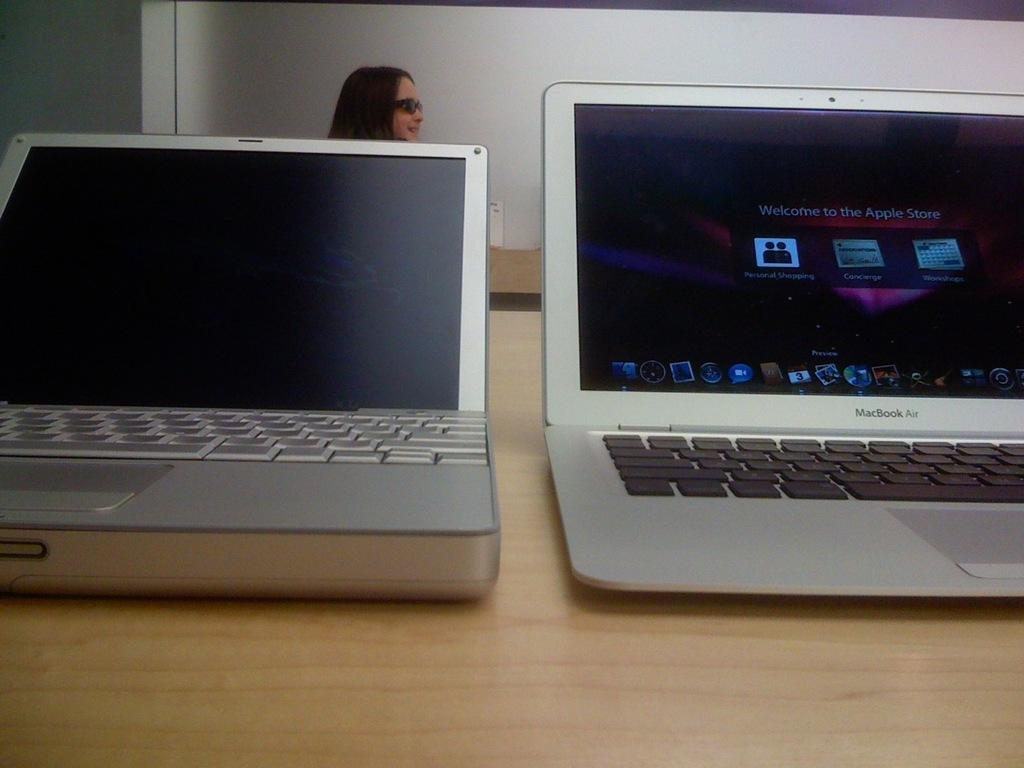<image>
Render a clear and concise summary of the photo. A MacBook Air is on a table next to another laptop. 